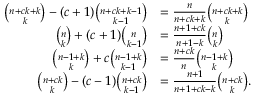Convert formula to latex. <formula><loc_0><loc_0><loc_500><loc_500>{ \begin{array} { r l } { { \binom { n + c k + k } { k } } - ( c + 1 ) { \binom { n + c k + k - 1 } { k - 1 } } } & { = { \frac { n } { n + c k + k } } { \binom { n + c k + k } { k } } } \\ { { \binom { n } { k } } + ( c + 1 ) { \binom { n } { k - 1 } } } & { = { \frac { n + 1 + c k } { n + 1 - k } } { \binom { n } { k } } } \\ { { \binom { n - 1 + k } { k } } + c { \binom { n - 1 + k } { k - 1 } } } & { = { \frac { n + c k } { n } } { \binom { n - 1 + k } { k } } } \\ { { \binom { n + c k } { k } } - ( c - 1 ) { \binom { n + c k } { k - 1 } } } & { = { \frac { n + 1 } { n + 1 + c k - k } } { \binom { n + c k } { k } } . } \end{array} }</formula> 